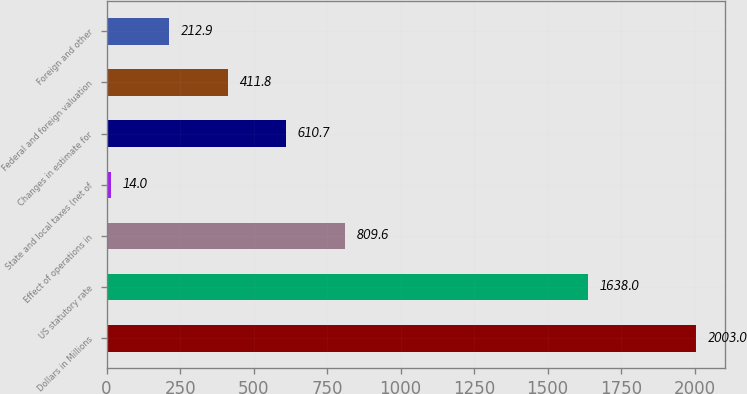Convert chart. <chart><loc_0><loc_0><loc_500><loc_500><bar_chart><fcel>Dollars in Millions<fcel>US statutory rate<fcel>Effect of operations in<fcel>State and local taxes (net of<fcel>Changes in estimate for<fcel>Federal and foreign valuation<fcel>Foreign and other<nl><fcel>2003<fcel>1638<fcel>809.6<fcel>14<fcel>610.7<fcel>411.8<fcel>212.9<nl></chart> 